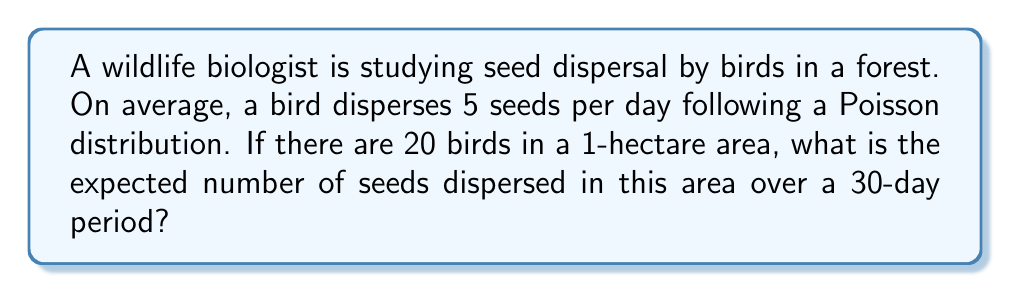Give your solution to this math problem. To solve this problem, we need to use the properties of the Poisson distribution and expected value calculations:

1. The Poisson distribution is used to model the number of events occurring in a fixed interval of time or space when these events happen with a known average rate.

2. For a Poisson distribution, the expected value (mean) is equal to the rate parameter λ.

3. In this case, for a single bird:
   λ (daily) = 5 seeds per day

4. For 20 birds:
   λ (daily for all birds) = 5 * 20 = 100 seeds per day

5. The time period is 30 days, so we need to multiply the daily rate by 30:
   λ (30 days for all birds) = 100 * 30 = 3000 seeds

6. The expected value of a Poisson distribution is equal to λ, so:
   E(X) = λ = 3000 seeds

Therefore, the expected number of seeds dispersed in the 1-hectare area over 30 days is 3000 seeds.

This calculation can be expressed mathematically as:

$$ E(X) = \lambda = n \cdot r \cdot t $$

Where:
- $n$ is the number of birds (20)
- $r$ is the average rate of seed dispersal per bird per day (5)
- $t$ is the number of days (30)

$$ E(X) = 20 \cdot 5 \cdot 30 = 3000 $$
Answer: The expected number of seeds dispersed in the 1-hectare area over 30 days is 3000 seeds. 